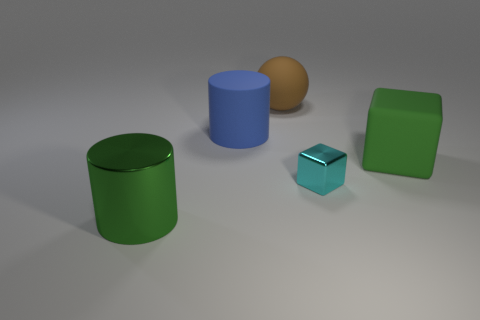Add 3 large brown things. How many objects exist? 8 Subtract all blocks. How many objects are left? 3 Add 4 large spheres. How many large spheres exist? 5 Subtract 0 brown cylinders. How many objects are left? 5 Subtract all purple spheres. Subtract all big green rubber cubes. How many objects are left? 4 Add 5 big green objects. How many big green objects are left? 7 